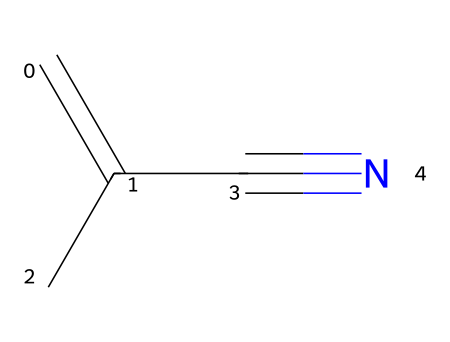What is the name of this chemical? The chemical structure provided corresponds to methacrylonitrile, as determined by analyzing the connectivity of the atoms, which reveals its specific arrangement and functional groups.
Answer: methacrylonitrile How many carbon atoms are in methacrylonitrile? By examining the SMILES representation, C=C(C)C#N, we count the carbon (C) symbols: there are four carbon atoms present in total.
Answer: 4 What type of bond connects the carbon atoms in this chemical? The structure contains a double bond between two carbon atoms (C=C) and a triple bond with the nitrogen (C#N), indicating different bond types: one double bond and one triple bond.
Answer: double and triple What functional group is present in methacrylonitrile? In methacrylonitrile, the nitrile group (-C≡N) is identifiable from the triple bond connecting the carbon to the nitrogen, which characterizes this as a nitrile.
Answer: nitrile What is the hybridization of the carbon atom in the nitrile group? The carbon in the nitrile group (C#N) is sp hybridized, as it forms a triple bond with nitrogen, consistent with the geometry and bonding characteristics of carbons involved in such configurations.
Answer: sp How does the presence of the double bond affect the reactivity of this compound? The double bond in methacrylonitrile contributes to its reactivity by allowing the molecule to participate in additional chemical reactions, such as addition reactions, which is typical for alkenes in organic compounds.
Answer: increases reactivity What is the primary use of methacrylonitrile in theater production? Methacrylonitrile is primarily utilized in adhesives, which are essential for securely attaching theatrical prosthetics to skin, highlighting its functional properties in performing arts applications.
Answer: adhesives 